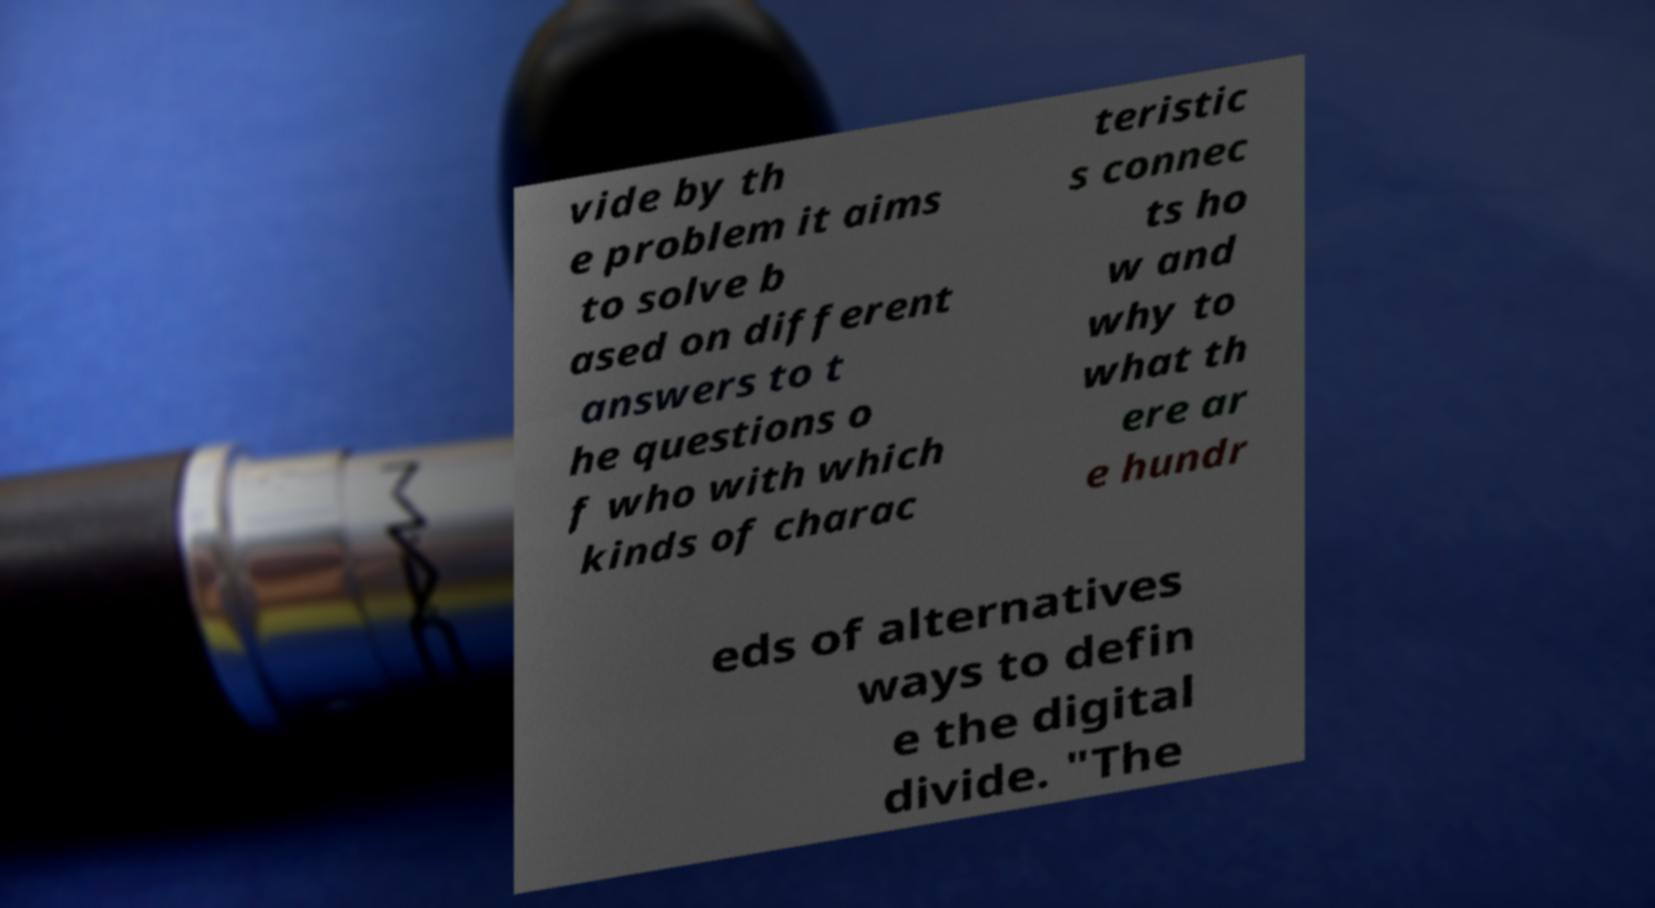Could you assist in decoding the text presented in this image and type it out clearly? vide by th e problem it aims to solve b ased on different answers to t he questions o f who with which kinds of charac teristic s connec ts ho w and why to what th ere ar e hundr eds of alternatives ways to defin e the digital divide. "The 